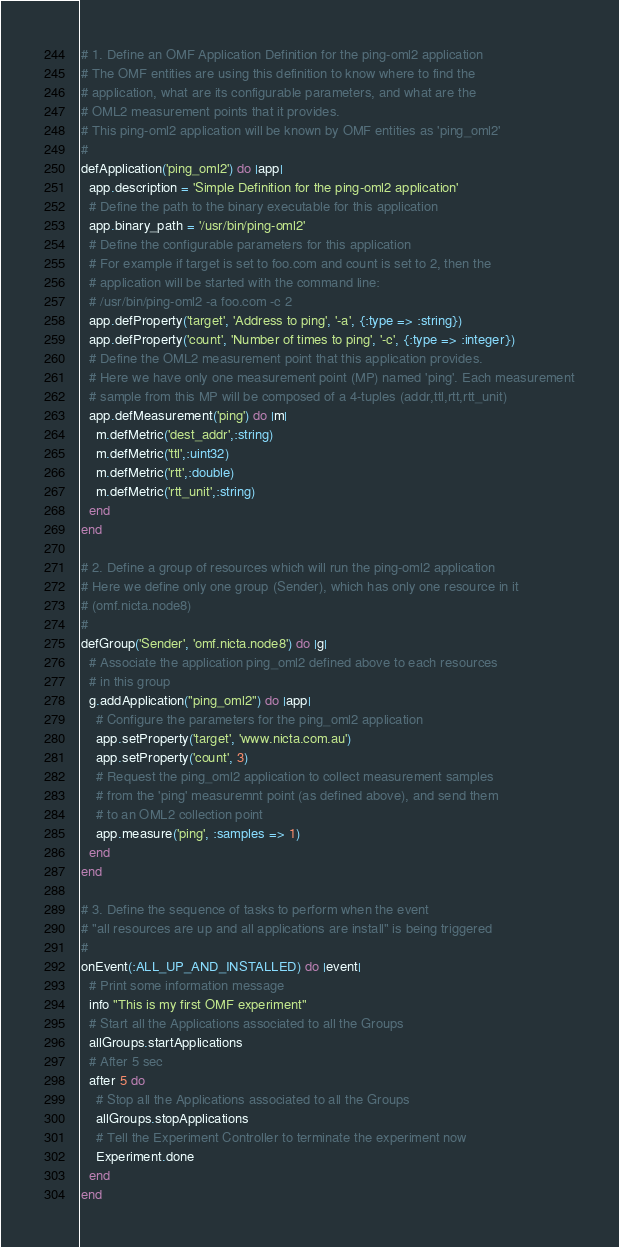<code> <loc_0><loc_0><loc_500><loc_500><_Ruby_># 1. Define an OMF Application Definition for the ping-oml2 application
# The OMF entities are using this definition to know where to find the
# application, what are its configurable parameters, and what are the
# OML2 measurement points that it provides.
# This ping-oml2 application will be known by OMF entities as 'ping_oml2'
#
defApplication('ping_oml2') do |app|
  app.description = 'Simple Definition for the ping-oml2 application'
  # Define the path to the binary executable for this application
  app.binary_path = '/usr/bin/ping-oml2'
  # Define the configurable parameters for this application
  # For example if target is set to foo.com and count is set to 2, then the
  # application will be started with the command line:
  # /usr/bin/ping-oml2 -a foo.com -c 2
  app.defProperty('target', 'Address to ping', '-a', {:type => :string})
  app.defProperty('count', 'Number of times to ping', '-c', {:type => :integer})
  # Define the OML2 measurement point that this application provides.
  # Here we have only one measurement point (MP) named 'ping'. Each measurement
  # sample from this MP will be composed of a 4-tuples (addr,ttl,rtt,rtt_unit)
  app.defMeasurement('ping') do |m|
    m.defMetric('dest_addr',:string)
    m.defMetric('ttl',:uint32)
    m.defMetric('rtt',:double)
    m.defMetric('rtt_unit',:string)
  end
end

# 2. Define a group of resources which will run the ping-oml2 application
# Here we define only one group (Sender), which has only one resource in it
# (omf.nicta.node8)
#
defGroup('Sender', 'omf.nicta.node8') do |g|
  # Associate the application ping_oml2 defined above to each resources
  # in this group
  g.addApplication("ping_oml2") do |app|
    # Configure the parameters for the ping_oml2 application
    app.setProperty('target', 'www.nicta.com.au')
    app.setProperty('count', 3)
    # Request the ping_oml2 application to collect measurement samples
    # from the 'ping' measuremnt point (as defined above), and send them
    # to an OML2 collection point
    app.measure('ping', :samples => 1)
  end
end

# 3. Define the sequence of tasks to perform when the event
# "all resources are up and all applications are install" is being triggered
#
onEvent(:ALL_UP_AND_INSTALLED) do |event|
  # Print some information message
  info "This is my first OMF experiment"
  # Start all the Applications associated to all the Groups
  allGroups.startApplications
  # After 5 sec
  after 5 do
    # Stop all the Applications associated to all the Groups
    allGroups.stopApplications
    # Tell the Experiment Controller to terminate the experiment now
    Experiment.done
  end
end
</code> 